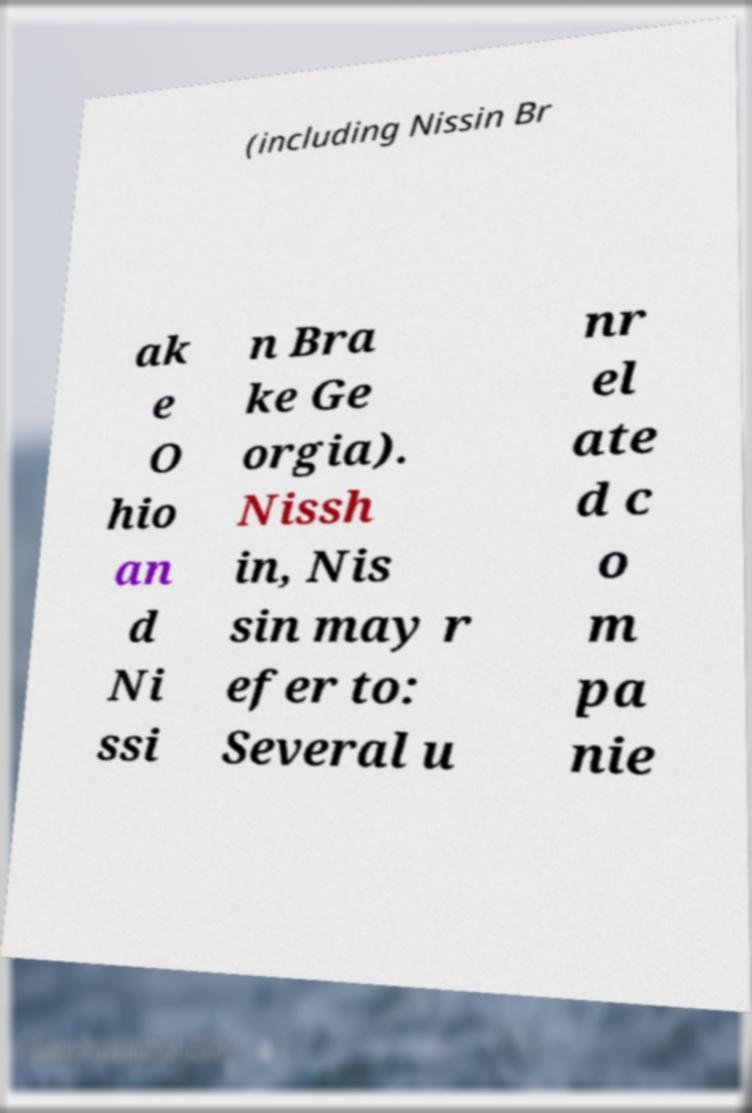Please read and relay the text visible in this image. What does it say? (including Nissin Br ak e O hio an d Ni ssi n Bra ke Ge orgia). Nissh in, Nis sin may r efer to: Several u nr el ate d c o m pa nie 